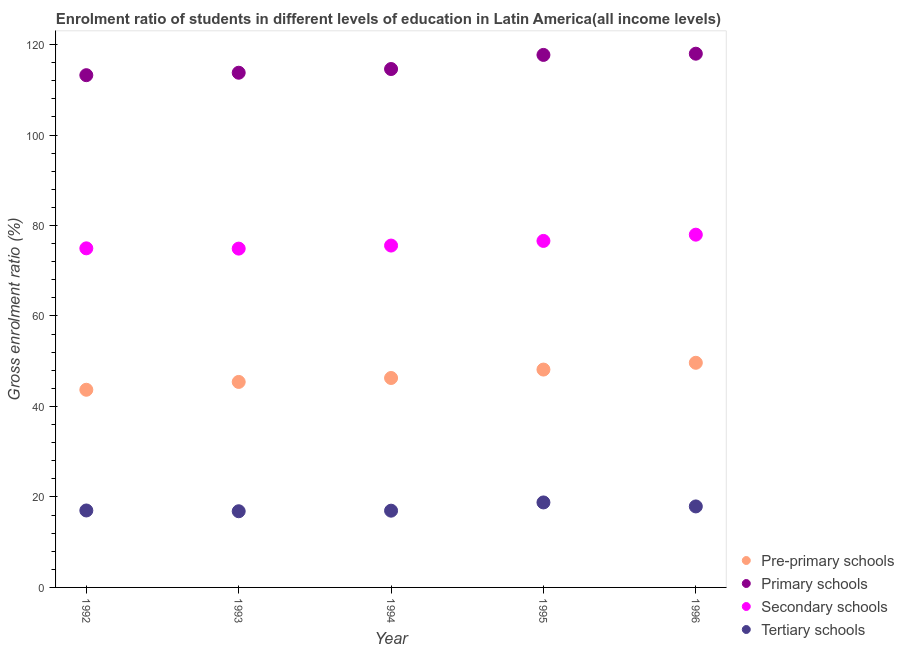How many different coloured dotlines are there?
Make the answer very short. 4. What is the gross enrolment ratio in pre-primary schools in 1993?
Your answer should be compact. 45.42. Across all years, what is the maximum gross enrolment ratio in primary schools?
Make the answer very short. 117.97. Across all years, what is the minimum gross enrolment ratio in secondary schools?
Offer a very short reply. 74.89. What is the total gross enrolment ratio in tertiary schools in the graph?
Your response must be concise. 87.5. What is the difference between the gross enrolment ratio in primary schools in 1992 and that in 1995?
Make the answer very short. -4.48. What is the difference between the gross enrolment ratio in secondary schools in 1993 and the gross enrolment ratio in pre-primary schools in 1992?
Keep it short and to the point. 31.2. What is the average gross enrolment ratio in secondary schools per year?
Keep it short and to the point. 75.99. In the year 1992, what is the difference between the gross enrolment ratio in tertiary schools and gross enrolment ratio in secondary schools?
Offer a terse response. -57.94. In how many years, is the gross enrolment ratio in pre-primary schools greater than 40 %?
Ensure brevity in your answer.  5. What is the ratio of the gross enrolment ratio in primary schools in 1994 to that in 1996?
Keep it short and to the point. 0.97. Is the gross enrolment ratio in secondary schools in 1993 less than that in 1994?
Offer a terse response. Yes. What is the difference between the highest and the second highest gross enrolment ratio in pre-primary schools?
Offer a very short reply. 1.5. What is the difference between the highest and the lowest gross enrolment ratio in secondary schools?
Provide a succinct answer. 3.08. In how many years, is the gross enrolment ratio in tertiary schools greater than the average gross enrolment ratio in tertiary schools taken over all years?
Provide a short and direct response. 2. Is the sum of the gross enrolment ratio in secondary schools in 1992 and 1994 greater than the maximum gross enrolment ratio in tertiary schools across all years?
Your response must be concise. Yes. Is it the case that in every year, the sum of the gross enrolment ratio in pre-primary schools and gross enrolment ratio in primary schools is greater than the gross enrolment ratio in secondary schools?
Your answer should be very brief. Yes. Is the gross enrolment ratio in primary schools strictly less than the gross enrolment ratio in secondary schools over the years?
Your answer should be very brief. No. How many dotlines are there?
Provide a short and direct response. 4. What is the difference between two consecutive major ticks on the Y-axis?
Your answer should be very brief. 20. Are the values on the major ticks of Y-axis written in scientific E-notation?
Provide a short and direct response. No. Does the graph contain any zero values?
Ensure brevity in your answer.  No. Does the graph contain grids?
Your answer should be compact. No. Where does the legend appear in the graph?
Your response must be concise. Bottom right. How many legend labels are there?
Provide a succinct answer. 4. What is the title of the graph?
Provide a short and direct response. Enrolment ratio of students in different levels of education in Latin America(all income levels). Does "Revenue mobilization" appear as one of the legend labels in the graph?
Make the answer very short. No. What is the label or title of the X-axis?
Provide a short and direct response. Year. What is the Gross enrolment ratio (%) of Pre-primary schools in 1992?
Offer a very short reply. 43.69. What is the Gross enrolment ratio (%) of Primary schools in 1992?
Give a very brief answer. 113.23. What is the Gross enrolment ratio (%) of Secondary schools in 1992?
Provide a succinct answer. 74.95. What is the Gross enrolment ratio (%) in Tertiary schools in 1992?
Offer a very short reply. 17.01. What is the Gross enrolment ratio (%) in Pre-primary schools in 1993?
Your response must be concise. 45.42. What is the Gross enrolment ratio (%) of Primary schools in 1993?
Give a very brief answer. 113.77. What is the Gross enrolment ratio (%) in Secondary schools in 1993?
Your answer should be compact. 74.89. What is the Gross enrolment ratio (%) in Tertiary schools in 1993?
Give a very brief answer. 16.84. What is the Gross enrolment ratio (%) of Pre-primary schools in 1994?
Offer a terse response. 46.29. What is the Gross enrolment ratio (%) of Primary schools in 1994?
Provide a short and direct response. 114.59. What is the Gross enrolment ratio (%) of Secondary schools in 1994?
Offer a very short reply. 75.56. What is the Gross enrolment ratio (%) in Tertiary schools in 1994?
Give a very brief answer. 16.97. What is the Gross enrolment ratio (%) of Pre-primary schools in 1995?
Provide a short and direct response. 48.16. What is the Gross enrolment ratio (%) of Primary schools in 1995?
Your response must be concise. 117.71. What is the Gross enrolment ratio (%) in Secondary schools in 1995?
Offer a very short reply. 76.59. What is the Gross enrolment ratio (%) of Tertiary schools in 1995?
Give a very brief answer. 18.78. What is the Gross enrolment ratio (%) in Pre-primary schools in 1996?
Offer a very short reply. 49.65. What is the Gross enrolment ratio (%) of Primary schools in 1996?
Give a very brief answer. 117.97. What is the Gross enrolment ratio (%) of Secondary schools in 1996?
Offer a very short reply. 77.97. What is the Gross enrolment ratio (%) of Tertiary schools in 1996?
Make the answer very short. 17.91. Across all years, what is the maximum Gross enrolment ratio (%) in Pre-primary schools?
Offer a terse response. 49.65. Across all years, what is the maximum Gross enrolment ratio (%) in Primary schools?
Offer a very short reply. 117.97. Across all years, what is the maximum Gross enrolment ratio (%) in Secondary schools?
Offer a very short reply. 77.97. Across all years, what is the maximum Gross enrolment ratio (%) in Tertiary schools?
Ensure brevity in your answer.  18.78. Across all years, what is the minimum Gross enrolment ratio (%) in Pre-primary schools?
Your response must be concise. 43.69. Across all years, what is the minimum Gross enrolment ratio (%) of Primary schools?
Give a very brief answer. 113.23. Across all years, what is the minimum Gross enrolment ratio (%) of Secondary schools?
Offer a very short reply. 74.89. Across all years, what is the minimum Gross enrolment ratio (%) in Tertiary schools?
Make the answer very short. 16.84. What is the total Gross enrolment ratio (%) of Pre-primary schools in the graph?
Give a very brief answer. 233.22. What is the total Gross enrolment ratio (%) in Primary schools in the graph?
Make the answer very short. 577.26. What is the total Gross enrolment ratio (%) of Secondary schools in the graph?
Offer a terse response. 379.97. What is the total Gross enrolment ratio (%) of Tertiary schools in the graph?
Make the answer very short. 87.5. What is the difference between the Gross enrolment ratio (%) of Pre-primary schools in 1992 and that in 1993?
Your response must be concise. -1.73. What is the difference between the Gross enrolment ratio (%) in Primary schools in 1992 and that in 1993?
Provide a short and direct response. -0.54. What is the difference between the Gross enrolment ratio (%) in Secondary schools in 1992 and that in 1993?
Your response must be concise. 0.06. What is the difference between the Gross enrolment ratio (%) of Tertiary schools in 1992 and that in 1993?
Give a very brief answer. 0.17. What is the difference between the Gross enrolment ratio (%) of Pre-primary schools in 1992 and that in 1994?
Your answer should be compact. -2.6. What is the difference between the Gross enrolment ratio (%) of Primary schools in 1992 and that in 1994?
Keep it short and to the point. -1.36. What is the difference between the Gross enrolment ratio (%) of Secondary schools in 1992 and that in 1994?
Make the answer very short. -0.61. What is the difference between the Gross enrolment ratio (%) of Tertiary schools in 1992 and that in 1994?
Provide a succinct answer. 0.04. What is the difference between the Gross enrolment ratio (%) in Pre-primary schools in 1992 and that in 1995?
Offer a very short reply. -4.46. What is the difference between the Gross enrolment ratio (%) of Primary schools in 1992 and that in 1995?
Ensure brevity in your answer.  -4.48. What is the difference between the Gross enrolment ratio (%) in Secondary schools in 1992 and that in 1995?
Offer a very short reply. -1.64. What is the difference between the Gross enrolment ratio (%) of Tertiary schools in 1992 and that in 1995?
Offer a very short reply. -1.78. What is the difference between the Gross enrolment ratio (%) of Pre-primary schools in 1992 and that in 1996?
Make the answer very short. -5.96. What is the difference between the Gross enrolment ratio (%) of Primary schools in 1992 and that in 1996?
Make the answer very short. -4.75. What is the difference between the Gross enrolment ratio (%) in Secondary schools in 1992 and that in 1996?
Provide a succinct answer. -3.02. What is the difference between the Gross enrolment ratio (%) of Tertiary schools in 1992 and that in 1996?
Provide a succinct answer. -0.9. What is the difference between the Gross enrolment ratio (%) in Pre-primary schools in 1993 and that in 1994?
Make the answer very short. -0.87. What is the difference between the Gross enrolment ratio (%) of Primary schools in 1993 and that in 1994?
Provide a succinct answer. -0.82. What is the difference between the Gross enrolment ratio (%) of Secondary schools in 1993 and that in 1994?
Your answer should be compact. -0.67. What is the difference between the Gross enrolment ratio (%) of Tertiary schools in 1993 and that in 1994?
Offer a terse response. -0.13. What is the difference between the Gross enrolment ratio (%) in Pre-primary schools in 1993 and that in 1995?
Offer a terse response. -2.73. What is the difference between the Gross enrolment ratio (%) of Primary schools in 1993 and that in 1995?
Give a very brief answer. -3.94. What is the difference between the Gross enrolment ratio (%) in Secondary schools in 1993 and that in 1995?
Provide a succinct answer. -1.7. What is the difference between the Gross enrolment ratio (%) in Tertiary schools in 1993 and that in 1995?
Provide a succinct answer. -1.95. What is the difference between the Gross enrolment ratio (%) in Pre-primary schools in 1993 and that in 1996?
Your answer should be very brief. -4.23. What is the difference between the Gross enrolment ratio (%) of Primary schools in 1993 and that in 1996?
Give a very brief answer. -4.21. What is the difference between the Gross enrolment ratio (%) in Secondary schools in 1993 and that in 1996?
Your answer should be very brief. -3.08. What is the difference between the Gross enrolment ratio (%) of Tertiary schools in 1993 and that in 1996?
Provide a short and direct response. -1.07. What is the difference between the Gross enrolment ratio (%) in Pre-primary schools in 1994 and that in 1995?
Provide a succinct answer. -1.86. What is the difference between the Gross enrolment ratio (%) in Primary schools in 1994 and that in 1995?
Provide a short and direct response. -3.12. What is the difference between the Gross enrolment ratio (%) in Secondary schools in 1994 and that in 1995?
Make the answer very short. -1.03. What is the difference between the Gross enrolment ratio (%) of Tertiary schools in 1994 and that in 1995?
Keep it short and to the point. -1.82. What is the difference between the Gross enrolment ratio (%) in Pre-primary schools in 1994 and that in 1996?
Make the answer very short. -3.36. What is the difference between the Gross enrolment ratio (%) of Primary schools in 1994 and that in 1996?
Keep it short and to the point. -3.39. What is the difference between the Gross enrolment ratio (%) of Secondary schools in 1994 and that in 1996?
Your answer should be compact. -2.41. What is the difference between the Gross enrolment ratio (%) of Tertiary schools in 1994 and that in 1996?
Offer a very short reply. -0.94. What is the difference between the Gross enrolment ratio (%) in Pre-primary schools in 1995 and that in 1996?
Your response must be concise. -1.5. What is the difference between the Gross enrolment ratio (%) in Primary schools in 1995 and that in 1996?
Your answer should be compact. -0.27. What is the difference between the Gross enrolment ratio (%) in Secondary schools in 1995 and that in 1996?
Your answer should be compact. -1.38. What is the difference between the Gross enrolment ratio (%) in Pre-primary schools in 1992 and the Gross enrolment ratio (%) in Primary schools in 1993?
Give a very brief answer. -70.08. What is the difference between the Gross enrolment ratio (%) in Pre-primary schools in 1992 and the Gross enrolment ratio (%) in Secondary schools in 1993?
Offer a terse response. -31.2. What is the difference between the Gross enrolment ratio (%) in Pre-primary schools in 1992 and the Gross enrolment ratio (%) in Tertiary schools in 1993?
Your response must be concise. 26.85. What is the difference between the Gross enrolment ratio (%) of Primary schools in 1992 and the Gross enrolment ratio (%) of Secondary schools in 1993?
Keep it short and to the point. 38.33. What is the difference between the Gross enrolment ratio (%) of Primary schools in 1992 and the Gross enrolment ratio (%) of Tertiary schools in 1993?
Offer a very short reply. 96.39. What is the difference between the Gross enrolment ratio (%) in Secondary schools in 1992 and the Gross enrolment ratio (%) in Tertiary schools in 1993?
Provide a succinct answer. 58.11. What is the difference between the Gross enrolment ratio (%) of Pre-primary schools in 1992 and the Gross enrolment ratio (%) of Primary schools in 1994?
Provide a short and direct response. -70.89. What is the difference between the Gross enrolment ratio (%) in Pre-primary schools in 1992 and the Gross enrolment ratio (%) in Secondary schools in 1994?
Ensure brevity in your answer.  -31.87. What is the difference between the Gross enrolment ratio (%) of Pre-primary schools in 1992 and the Gross enrolment ratio (%) of Tertiary schools in 1994?
Offer a very short reply. 26.73. What is the difference between the Gross enrolment ratio (%) in Primary schools in 1992 and the Gross enrolment ratio (%) in Secondary schools in 1994?
Provide a succinct answer. 37.66. What is the difference between the Gross enrolment ratio (%) of Primary schools in 1992 and the Gross enrolment ratio (%) of Tertiary schools in 1994?
Provide a short and direct response. 96.26. What is the difference between the Gross enrolment ratio (%) in Secondary schools in 1992 and the Gross enrolment ratio (%) in Tertiary schools in 1994?
Offer a very short reply. 57.99. What is the difference between the Gross enrolment ratio (%) in Pre-primary schools in 1992 and the Gross enrolment ratio (%) in Primary schools in 1995?
Your response must be concise. -74.01. What is the difference between the Gross enrolment ratio (%) of Pre-primary schools in 1992 and the Gross enrolment ratio (%) of Secondary schools in 1995?
Make the answer very short. -32.9. What is the difference between the Gross enrolment ratio (%) in Pre-primary schools in 1992 and the Gross enrolment ratio (%) in Tertiary schools in 1995?
Your answer should be compact. 24.91. What is the difference between the Gross enrolment ratio (%) in Primary schools in 1992 and the Gross enrolment ratio (%) in Secondary schools in 1995?
Offer a terse response. 36.63. What is the difference between the Gross enrolment ratio (%) in Primary schools in 1992 and the Gross enrolment ratio (%) in Tertiary schools in 1995?
Give a very brief answer. 94.44. What is the difference between the Gross enrolment ratio (%) in Secondary schools in 1992 and the Gross enrolment ratio (%) in Tertiary schools in 1995?
Keep it short and to the point. 56.17. What is the difference between the Gross enrolment ratio (%) of Pre-primary schools in 1992 and the Gross enrolment ratio (%) of Primary schools in 1996?
Make the answer very short. -74.28. What is the difference between the Gross enrolment ratio (%) of Pre-primary schools in 1992 and the Gross enrolment ratio (%) of Secondary schools in 1996?
Make the answer very short. -34.28. What is the difference between the Gross enrolment ratio (%) in Pre-primary schools in 1992 and the Gross enrolment ratio (%) in Tertiary schools in 1996?
Your response must be concise. 25.79. What is the difference between the Gross enrolment ratio (%) in Primary schools in 1992 and the Gross enrolment ratio (%) in Secondary schools in 1996?
Provide a succinct answer. 35.25. What is the difference between the Gross enrolment ratio (%) in Primary schools in 1992 and the Gross enrolment ratio (%) in Tertiary schools in 1996?
Provide a succinct answer. 95.32. What is the difference between the Gross enrolment ratio (%) in Secondary schools in 1992 and the Gross enrolment ratio (%) in Tertiary schools in 1996?
Provide a short and direct response. 57.05. What is the difference between the Gross enrolment ratio (%) of Pre-primary schools in 1993 and the Gross enrolment ratio (%) of Primary schools in 1994?
Offer a terse response. -69.16. What is the difference between the Gross enrolment ratio (%) in Pre-primary schools in 1993 and the Gross enrolment ratio (%) in Secondary schools in 1994?
Ensure brevity in your answer.  -30.14. What is the difference between the Gross enrolment ratio (%) of Pre-primary schools in 1993 and the Gross enrolment ratio (%) of Tertiary schools in 1994?
Offer a very short reply. 28.46. What is the difference between the Gross enrolment ratio (%) in Primary schools in 1993 and the Gross enrolment ratio (%) in Secondary schools in 1994?
Make the answer very short. 38.2. What is the difference between the Gross enrolment ratio (%) of Primary schools in 1993 and the Gross enrolment ratio (%) of Tertiary schools in 1994?
Provide a short and direct response. 96.8. What is the difference between the Gross enrolment ratio (%) in Secondary schools in 1993 and the Gross enrolment ratio (%) in Tertiary schools in 1994?
Your response must be concise. 57.93. What is the difference between the Gross enrolment ratio (%) of Pre-primary schools in 1993 and the Gross enrolment ratio (%) of Primary schools in 1995?
Offer a very short reply. -72.28. What is the difference between the Gross enrolment ratio (%) in Pre-primary schools in 1993 and the Gross enrolment ratio (%) in Secondary schools in 1995?
Your response must be concise. -31.17. What is the difference between the Gross enrolment ratio (%) of Pre-primary schools in 1993 and the Gross enrolment ratio (%) of Tertiary schools in 1995?
Your answer should be compact. 26.64. What is the difference between the Gross enrolment ratio (%) in Primary schools in 1993 and the Gross enrolment ratio (%) in Secondary schools in 1995?
Offer a terse response. 37.18. What is the difference between the Gross enrolment ratio (%) of Primary schools in 1993 and the Gross enrolment ratio (%) of Tertiary schools in 1995?
Offer a terse response. 94.98. What is the difference between the Gross enrolment ratio (%) in Secondary schools in 1993 and the Gross enrolment ratio (%) in Tertiary schools in 1995?
Give a very brief answer. 56.11. What is the difference between the Gross enrolment ratio (%) of Pre-primary schools in 1993 and the Gross enrolment ratio (%) of Primary schools in 1996?
Give a very brief answer. -72.55. What is the difference between the Gross enrolment ratio (%) in Pre-primary schools in 1993 and the Gross enrolment ratio (%) in Secondary schools in 1996?
Ensure brevity in your answer.  -32.55. What is the difference between the Gross enrolment ratio (%) of Pre-primary schools in 1993 and the Gross enrolment ratio (%) of Tertiary schools in 1996?
Offer a very short reply. 27.52. What is the difference between the Gross enrolment ratio (%) in Primary schools in 1993 and the Gross enrolment ratio (%) in Secondary schools in 1996?
Provide a succinct answer. 35.8. What is the difference between the Gross enrolment ratio (%) in Primary schools in 1993 and the Gross enrolment ratio (%) in Tertiary schools in 1996?
Your answer should be compact. 95.86. What is the difference between the Gross enrolment ratio (%) in Secondary schools in 1993 and the Gross enrolment ratio (%) in Tertiary schools in 1996?
Your answer should be compact. 56.99. What is the difference between the Gross enrolment ratio (%) in Pre-primary schools in 1994 and the Gross enrolment ratio (%) in Primary schools in 1995?
Offer a terse response. -71.41. What is the difference between the Gross enrolment ratio (%) in Pre-primary schools in 1994 and the Gross enrolment ratio (%) in Secondary schools in 1995?
Offer a terse response. -30.3. What is the difference between the Gross enrolment ratio (%) in Pre-primary schools in 1994 and the Gross enrolment ratio (%) in Tertiary schools in 1995?
Your response must be concise. 27.51. What is the difference between the Gross enrolment ratio (%) in Primary schools in 1994 and the Gross enrolment ratio (%) in Secondary schools in 1995?
Offer a terse response. 38. What is the difference between the Gross enrolment ratio (%) in Primary schools in 1994 and the Gross enrolment ratio (%) in Tertiary schools in 1995?
Your answer should be very brief. 95.8. What is the difference between the Gross enrolment ratio (%) of Secondary schools in 1994 and the Gross enrolment ratio (%) of Tertiary schools in 1995?
Give a very brief answer. 56.78. What is the difference between the Gross enrolment ratio (%) of Pre-primary schools in 1994 and the Gross enrolment ratio (%) of Primary schools in 1996?
Keep it short and to the point. -71.68. What is the difference between the Gross enrolment ratio (%) of Pre-primary schools in 1994 and the Gross enrolment ratio (%) of Secondary schools in 1996?
Offer a terse response. -31.68. What is the difference between the Gross enrolment ratio (%) of Pre-primary schools in 1994 and the Gross enrolment ratio (%) of Tertiary schools in 1996?
Give a very brief answer. 28.39. What is the difference between the Gross enrolment ratio (%) in Primary schools in 1994 and the Gross enrolment ratio (%) in Secondary schools in 1996?
Your answer should be compact. 36.61. What is the difference between the Gross enrolment ratio (%) in Primary schools in 1994 and the Gross enrolment ratio (%) in Tertiary schools in 1996?
Offer a very short reply. 96.68. What is the difference between the Gross enrolment ratio (%) of Secondary schools in 1994 and the Gross enrolment ratio (%) of Tertiary schools in 1996?
Keep it short and to the point. 57.66. What is the difference between the Gross enrolment ratio (%) in Pre-primary schools in 1995 and the Gross enrolment ratio (%) in Primary schools in 1996?
Make the answer very short. -69.82. What is the difference between the Gross enrolment ratio (%) in Pre-primary schools in 1995 and the Gross enrolment ratio (%) in Secondary schools in 1996?
Your answer should be very brief. -29.82. What is the difference between the Gross enrolment ratio (%) in Pre-primary schools in 1995 and the Gross enrolment ratio (%) in Tertiary schools in 1996?
Your answer should be very brief. 30.25. What is the difference between the Gross enrolment ratio (%) in Primary schools in 1995 and the Gross enrolment ratio (%) in Secondary schools in 1996?
Offer a very short reply. 39.73. What is the difference between the Gross enrolment ratio (%) in Primary schools in 1995 and the Gross enrolment ratio (%) in Tertiary schools in 1996?
Give a very brief answer. 99.8. What is the difference between the Gross enrolment ratio (%) in Secondary schools in 1995 and the Gross enrolment ratio (%) in Tertiary schools in 1996?
Offer a very short reply. 58.69. What is the average Gross enrolment ratio (%) of Pre-primary schools per year?
Keep it short and to the point. 46.64. What is the average Gross enrolment ratio (%) in Primary schools per year?
Your answer should be very brief. 115.45. What is the average Gross enrolment ratio (%) in Secondary schools per year?
Offer a very short reply. 75.99. What is the average Gross enrolment ratio (%) of Tertiary schools per year?
Your answer should be very brief. 17.5. In the year 1992, what is the difference between the Gross enrolment ratio (%) in Pre-primary schools and Gross enrolment ratio (%) in Primary schools?
Make the answer very short. -69.53. In the year 1992, what is the difference between the Gross enrolment ratio (%) in Pre-primary schools and Gross enrolment ratio (%) in Secondary schools?
Provide a succinct answer. -31.26. In the year 1992, what is the difference between the Gross enrolment ratio (%) of Pre-primary schools and Gross enrolment ratio (%) of Tertiary schools?
Your answer should be compact. 26.68. In the year 1992, what is the difference between the Gross enrolment ratio (%) in Primary schools and Gross enrolment ratio (%) in Secondary schools?
Your answer should be very brief. 38.27. In the year 1992, what is the difference between the Gross enrolment ratio (%) in Primary schools and Gross enrolment ratio (%) in Tertiary schools?
Your response must be concise. 96.22. In the year 1992, what is the difference between the Gross enrolment ratio (%) of Secondary schools and Gross enrolment ratio (%) of Tertiary schools?
Your response must be concise. 57.94. In the year 1993, what is the difference between the Gross enrolment ratio (%) in Pre-primary schools and Gross enrolment ratio (%) in Primary schools?
Keep it short and to the point. -68.35. In the year 1993, what is the difference between the Gross enrolment ratio (%) of Pre-primary schools and Gross enrolment ratio (%) of Secondary schools?
Give a very brief answer. -29.47. In the year 1993, what is the difference between the Gross enrolment ratio (%) of Pre-primary schools and Gross enrolment ratio (%) of Tertiary schools?
Ensure brevity in your answer.  28.58. In the year 1993, what is the difference between the Gross enrolment ratio (%) in Primary schools and Gross enrolment ratio (%) in Secondary schools?
Ensure brevity in your answer.  38.88. In the year 1993, what is the difference between the Gross enrolment ratio (%) in Primary schools and Gross enrolment ratio (%) in Tertiary schools?
Offer a very short reply. 96.93. In the year 1993, what is the difference between the Gross enrolment ratio (%) in Secondary schools and Gross enrolment ratio (%) in Tertiary schools?
Your answer should be compact. 58.05. In the year 1994, what is the difference between the Gross enrolment ratio (%) of Pre-primary schools and Gross enrolment ratio (%) of Primary schools?
Make the answer very short. -68.29. In the year 1994, what is the difference between the Gross enrolment ratio (%) of Pre-primary schools and Gross enrolment ratio (%) of Secondary schools?
Ensure brevity in your answer.  -29.27. In the year 1994, what is the difference between the Gross enrolment ratio (%) of Pre-primary schools and Gross enrolment ratio (%) of Tertiary schools?
Your answer should be very brief. 29.33. In the year 1994, what is the difference between the Gross enrolment ratio (%) of Primary schools and Gross enrolment ratio (%) of Secondary schools?
Provide a succinct answer. 39.02. In the year 1994, what is the difference between the Gross enrolment ratio (%) in Primary schools and Gross enrolment ratio (%) in Tertiary schools?
Offer a very short reply. 97.62. In the year 1994, what is the difference between the Gross enrolment ratio (%) in Secondary schools and Gross enrolment ratio (%) in Tertiary schools?
Give a very brief answer. 58.6. In the year 1995, what is the difference between the Gross enrolment ratio (%) in Pre-primary schools and Gross enrolment ratio (%) in Primary schools?
Offer a very short reply. -69.55. In the year 1995, what is the difference between the Gross enrolment ratio (%) of Pre-primary schools and Gross enrolment ratio (%) of Secondary schools?
Offer a terse response. -28.44. In the year 1995, what is the difference between the Gross enrolment ratio (%) in Pre-primary schools and Gross enrolment ratio (%) in Tertiary schools?
Give a very brief answer. 29.37. In the year 1995, what is the difference between the Gross enrolment ratio (%) of Primary schools and Gross enrolment ratio (%) of Secondary schools?
Give a very brief answer. 41.11. In the year 1995, what is the difference between the Gross enrolment ratio (%) in Primary schools and Gross enrolment ratio (%) in Tertiary schools?
Make the answer very short. 98.92. In the year 1995, what is the difference between the Gross enrolment ratio (%) of Secondary schools and Gross enrolment ratio (%) of Tertiary schools?
Keep it short and to the point. 57.81. In the year 1996, what is the difference between the Gross enrolment ratio (%) of Pre-primary schools and Gross enrolment ratio (%) of Primary schools?
Offer a terse response. -68.32. In the year 1996, what is the difference between the Gross enrolment ratio (%) of Pre-primary schools and Gross enrolment ratio (%) of Secondary schools?
Your answer should be compact. -28.32. In the year 1996, what is the difference between the Gross enrolment ratio (%) in Pre-primary schools and Gross enrolment ratio (%) in Tertiary schools?
Provide a short and direct response. 31.75. In the year 1996, what is the difference between the Gross enrolment ratio (%) of Primary schools and Gross enrolment ratio (%) of Secondary schools?
Provide a short and direct response. 40. In the year 1996, what is the difference between the Gross enrolment ratio (%) in Primary schools and Gross enrolment ratio (%) in Tertiary schools?
Keep it short and to the point. 100.07. In the year 1996, what is the difference between the Gross enrolment ratio (%) of Secondary schools and Gross enrolment ratio (%) of Tertiary schools?
Make the answer very short. 60.07. What is the ratio of the Gross enrolment ratio (%) in Pre-primary schools in 1992 to that in 1993?
Keep it short and to the point. 0.96. What is the ratio of the Gross enrolment ratio (%) in Secondary schools in 1992 to that in 1993?
Offer a terse response. 1. What is the ratio of the Gross enrolment ratio (%) of Tertiary schools in 1992 to that in 1993?
Give a very brief answer. 1.01. What is the ratio of the Gross enrolment ratio (%) of Pre-primary schools in 1992 to that in 1994?
Ensure brevity in your answer.  0.94. What is the ratio of the Gross enrolment ratio (%) in Primary schools in 1992 to that in 1994?
Provide a succinct answer. 0.99. What is the ratio of the Gross enrolment ratio (%) in Tertiary schools in 1992 to that in 1994?
Give a very brief answer. 1. What is the ratio of the Gross enrolment ratio (%) of Pre-primary schools in 1992 to that in 1995?
Keep it short and to the point. 0.91. What is the ratio of the Gross enrolment ratio (%) in Primary schools in 1992 to that in 1995?
Make the answer very short. 0.96. What is the ratio of the Gross enrolment ratio (%) in Secondary schools in 1992 to that in 1995?
Make the answer very short. 0.98. What is the ratio of the Gross enrolment ratio (%) in Tertiary schools in 1992 to that in 1995?
Give a very brief answer. 0.91. What is the ratio of the Gross enrolment ratio (%) in Pre-primary schools in 1992 to that in 1996?
Ensure brevity in your answer.  0.88. What is the ratio of the Gross enrolment ratio (%) in Primary schools in 1992 to that in 1996?
Ensure brevity in your answer.  0.96. What is the ratio of the Gross enrolment ratio (%) in Secondary schools in 1992 to that in 1996?
Keep it short and to the point. 0.96. What is the ratio of the Gross enrolment ratio (%) in Tertiary schools in 1992 to that in 1996?
Keep it short and to the point. 0.95. What is the ratio of the Gross enrolment ratio (%) of Pre-primary schools in 1993 to that in 1994?
Your answer should be compact. 0.98. What is the ratio of the Gross enrolment ratio (%) of Secondary schools in 1993 to that in 1994?
Ensure brevity in your answer.  0.99. What is the ratio of the Gross enrolment ratio (%) in Tertiary schools in 1993 to that in 1994?
Make the answer very short. 0.99. What is the ratio of the Gross enrolment ratio (%) in Pre-primary schools in 1993 to that in 1995?
Keep it short and to the point. 0.94. What is the ratio of the Gross enrolment ratio (%) of Primary schools in 1993 to that in 1995?
Your answer should be very brief. 0.97. What is the ratio of the Gross enrolment ratio (%) of Secondary schools in 1993 to that in 1995?
Your answer should be compact. 0.98. What is the ratio of the Gross enrolment ratio (%) in Tertiary schools in 1993 to that in 1995?
Keep it short and to the point. 0.9. What is the ratio of the Gross enrolment ratio (%) of Pre-primary schools in 1993 to that in 1996?
Your response must be concise. 0.91. What is the ratio of the Gross enrolment ratio (%) of Secondary schools in 1993 to that in 1996?
Your answer should be very brief. 0.96. What is the ratio of the Gross enrolment ratio (%) of Tertiary schools in 1993 to that in 1996?
Your response must be concise. 0.94. What is the ratio of the Gross enrolment ratio (%) of Pre-primary schools in 1994 to that in 1995?
Provide a short and direct response. 0.96. What is the ratio of the Gross enrolment ratio (%) of Primary schools in 1994 to that in 1995?
Keep it short and to the point. 0.97. What is the ratio of the Gross enrolment ratio (%) in Secondary schools in 1994 to that in 1995?
Provide a succinct answer. 0.99. What is the ratio of the Gross enrolment ratio (%) of Tertiary schools in 1994 to that in 1995?
Your answer should be compact. 0.9. What is the ratio of the Gross enrolment ratio (%) of Pre-primary schools in 1994 to that in 1996?
Offer a terse response. 0.93. What is the ratio of the Gross enrolment ratio (%) of Primary schools in 1994 to that in 1996?
Make the answer very short. 0.97. What is the ratio of the Gross enrolment ratio (%) of Secondary schools in 1994 to that in 1996?
Offer a very short reply. 0.97. What is the ratio of the Gross enrolment ratio (%) of Tertiary schools in 1994 to that in 1996?
Your response must be concise. 0.95. What is the ratio of the Gross enrolment ratio (%) in Pre-primary schools in 1995 to that in 1996?
Provide a short and direct response. 0.97. What is the ratio of the Gross enrolment ratio (%) in Primary schools in 1995 to that in 1996?
Offer a very short reply. 1. What is the ratio of the Gross enrolment ratio (%) of Secondary schools in 1995 to that in 1996?
Your response must be concise. 0.98. What is the ratio of the Gross enrolment ratio (%) of Tertiary schools in 1995 to that in 1996?
Ensure brevity in your answer.  1.05. What is the difference between the highest and the second highest Gross enrolment ratio (%) in Pre-primary schools?
Provide a succinct answer. 1.5. What is the difference between the highest and the second highest Gross enrolment ratio (%) of Primary schools?
Your answer should be very brief. 0.27. What is the difference between the highest and the second highest Gross enrolment ratio (%) in Secondary schools?
Make the answer very short. 1.38. What is the difference between the highest and the lowest Gross enrolment ratio (%) in Pre-primary schools?
Keep it short and to the point. 5.96. What is the difference between the highest and the lowest Gross enrolment ratio (%) in Primary schools?
Make the answer very short. 4.75. What is the difference between the highest and the lowest Gross enrolment ratio (%) of Secondary schools?
Make the answer very short. 3.08. What is the difference between the highest and the lowest Gross enrolment ratio (%) in Tertiary schools?
Your answer should be compact. 1.95. 